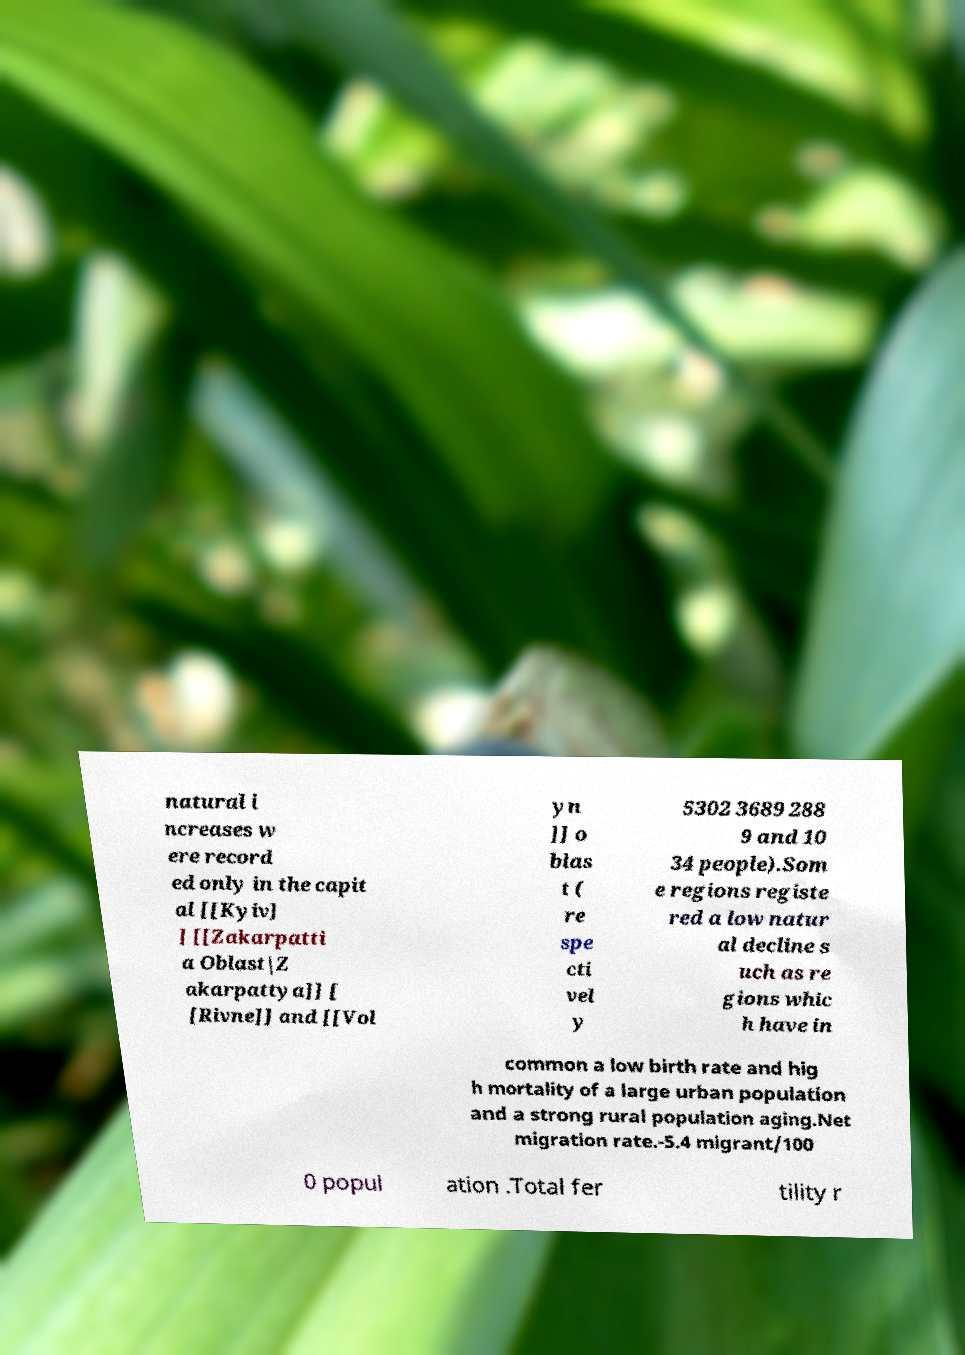What messages or text are displayed in this image? I need them in a readable, typed format. natural i ncreases w ere record ed only in the capit al [[Kyiv] ] [[Zakarpatti a Oblast|Z akarpattya]] [ [Rivne]] and [[Vol yn ]] o blas t ( re spe cti vel y 5302 3689 288 9 and 10 34 people).Som e regions registe red a low natur al decline s uch as re gions whic h have in common a low birth rate and hig h mortality of a large urban population and a strong rural population aging.Net migration rate.-5.4 migrant/100 0 popul ation .Total fer tility r 